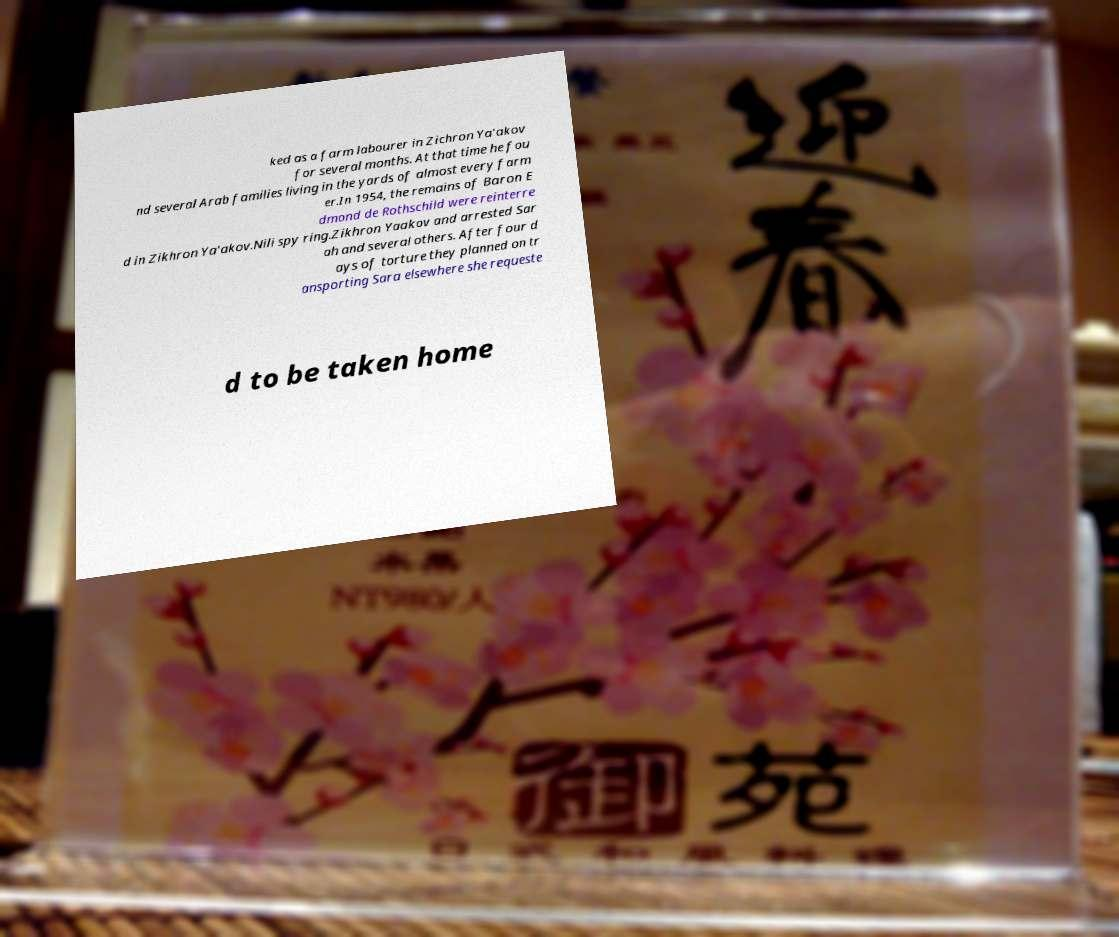Can you read and provide the text displayed in the image?This photo seems to have some interesting text. Can you extract and type it out for me? ked as a farm labourer in Zichron Ya'akov for several months. At that time he fou nd several Arab families living in the yards of almost every farm er.In 1954, the remains of Baron E dmond de Rothschild were reinterre d in Zikhron Ya'akov.Nili spy ring.Zikhron Yaakov and arrested Sar ah and several others. After four d ays of torture they planned on tr ansporting Sara elsewhere she requeste d to be taken home 